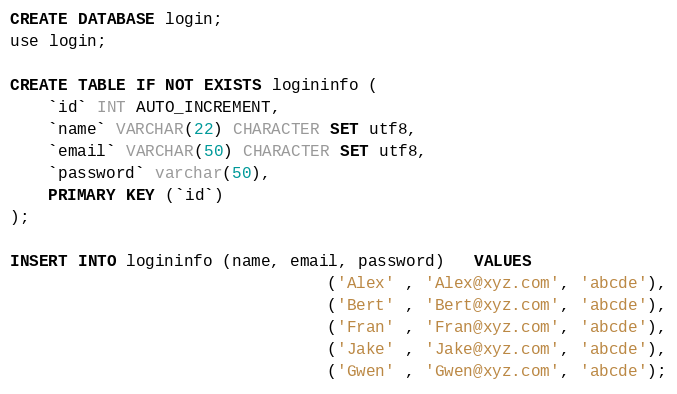<code> <loc_0><loc_0><loc_500><loc_500><_SQL_>CREATE DATABASE login;
use login;

CREATE TABLE IF NOT EXISTS logininfo (
    `id` INT AUTO_INCREMENT,
    `name` VARCHAR(22) CHARACTER SET utf8,
    `email` VARCHAR(50) CHARACTER SET utf8,
    `password` varchar(50),
    PRIMARY KEY (`id`)
);

INSERT INTO logininfo (name, email, password)   VALUES
                                 ('Alex' , 'Alex@xyz.com', 'abcde'),
                                 ('Bert' , 'Bert@xyz.com', 'abcde'),
                                 ('Fran' , 'Fran@xyz.com', 'abcde'),
                                 ('Jake' , 'Jake@xyz.com', 'abcde'),
                                 ('Gwen' , 'Gwen@xyz.com', 'abcde');
</code> 